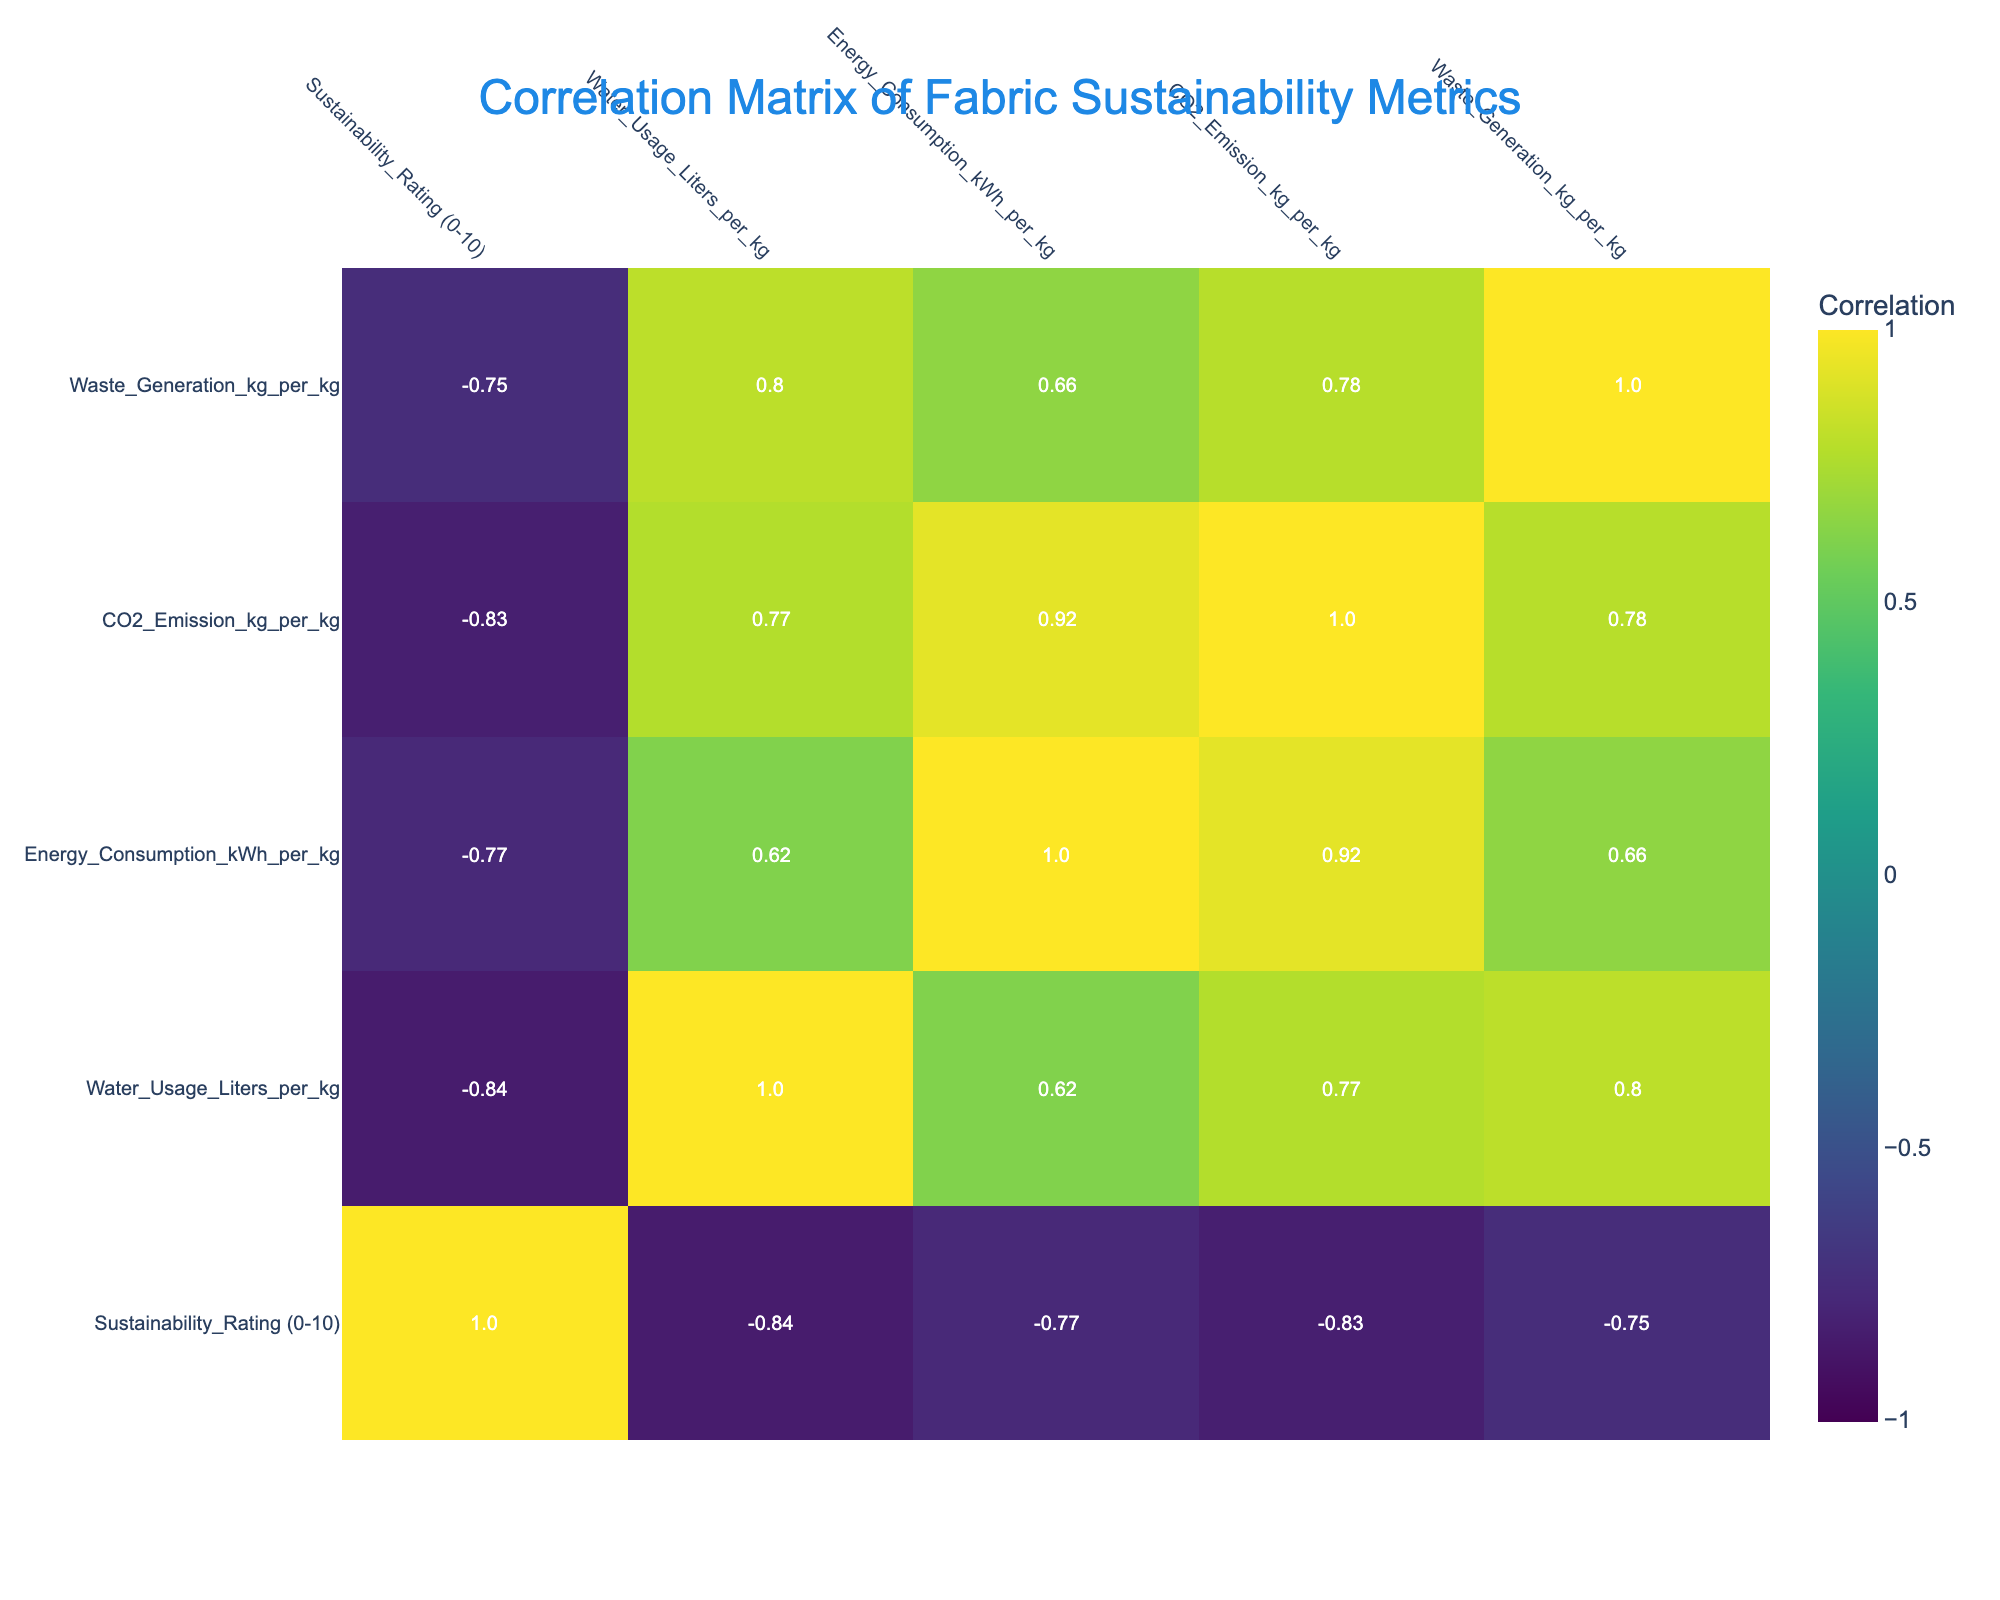What is the sustainability rating of Organic Cotton? The sustainability rating for Organic Cotton is provided directly in the table under the column "Sustainability_Rating (0-10)." It shows a value of 8.
Answer: 8 What is the CO2 emission per kg for Conventional Cotton? The table indicates the CO2 emission for Conventional Cotton in the "CO2_Emission_kg_per_kg" column, which is 2.0 kg per kg of fabric produced.
Answer: 2.0 Which fabric type has the highest sustainability rating? Reviewing the "Sustainability_Rating (0-10)" column, Hemp has the highest rating of 9, which is higher than all other fabrics listed.
Answer: Hemp Is the water usage for Recycled Polyester higher than for Tencel Derived? By comparing the "Water_Usage_Liters_per_kg" column, Recycled Polyester has a water usage of 300 liters per kg, and Tencel Derived has 250 liters per kg. Since 300 is greater than 250, the answer is yes.
Answer: Yes What is the average energy consumption of all the fabrics listed? To find the average energy consumption, sum up the energy consumption values: 2.5 + 3.5 + 4 + 5 + 1.5 + 2 + 2 + 4 + 3 + 2.5 = 26, then divide by the number of fabrics (10): 26/10 = 2.6 kWh per kg.
Answer: 2.6 Is there any fabric that generates zero waste? None of the entries in the "Waste_Generation_kg_per_kg" column show a value of zero. The minimum waste generation is 0.1 kg per kg for Hemp. Hence, there is no fabric with zero waste generation.
Answer: No How much more energy does New Polyester consume compared to Organic Cotton? The values in the "Energy_Consumption_kWh_per_kg" column show that New Polyester consumes 5 kWh per kg and Organic Cotton consumes 2.5 kWh per kg. By subtracting the two values (5 - 2.5), we find that New Polyester consumes 2.5 kWh more.
Answer: 2.5 kWh Which fabric types have a sustainability rating above 6? By reviewing the "Sustainability_Rating (0-10)" column, the fabrics with ratings above 6 are Organic Cotton, Hemp, Recycled Polyester, Tencel Derived, and Eco-Friendly Dyed Cotton. These can be listed as: Organic Cotton, Hemp, Recycled Polyester, Tencel Derived, Eco-Friendly Dyed Cotton.
Answer: Organic Cotton, Hemp, Recycled Polyester, Tencel Derived, Eco-Friendly Dyed Cotton What is the difference in sustainability rating between the best (Hemp) and the worst (New Polyester)? The sustainability ratings are 9 for Hemp and 3 for New Polyester. The difference is calculated by subtracting the lower rating from the higher one: 9 - 3 = 6.
Answer: 6 